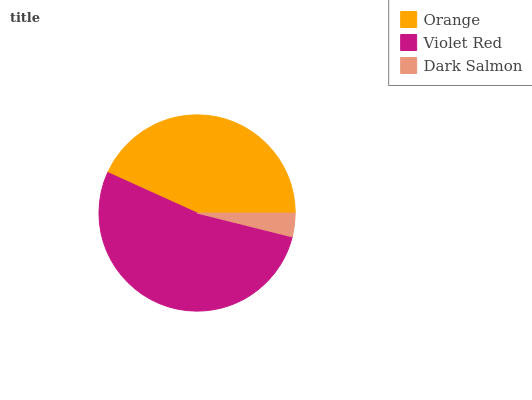Is Dark Salmon the minimum?
Answer yes or no. Yes. Is Violet Red the maximum?
Answer yes or no. Yes. Is Violet Red the minimum?
Answer yes or no. No. Is Dark Salmon the maximum?
Answer yes or no. No. Is Violet Red greater than Dark Salmon?
Answer yes or no. Yes. Is Dark Salmon less than Violet Red?
Answer yes or no. Yes. Is Dark Salmon greater than Violet Red?
Answer yes or no. No. Is Violet Red less than Dark Salmon?
Answer yes or no. No. Is Orange the high median?
Answer yes or no. Yes. Is Orange the low median?
Answer yes or no. Yes. Is Violet Red the high median?
Answer yes or no. No. Is Violet Red the low median?
Answer yes or no. No. 